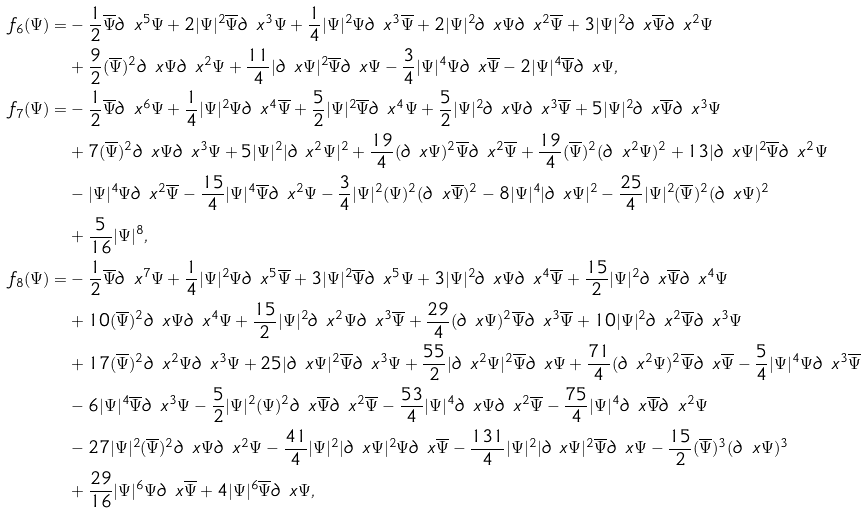<formula> <loc_0><loc_0><loc_500><loc_500>f _ { 6 } ( \Psi ) = & - \frac { 1 } { 2 } \overline { \Psi } \partial _ { \ } x ^ { 5 } \Psi + 2 | \Psi | ^ { 2 } \overline { \Psi } \partial _ { \ } x ^ { 3 } \Psi + \frac { 1 } { 4 } | \Psi | ^ { 2 } \Psi \partial _ { \ } x ^ { 3 } \overline { \Psi } + 2 | \Psi | ^ { 2 } \partial _ { \ } x \Psi \partial _ { \ } x ^ { 2 } \overline { \Psi } + 3 | \Psi | ^ { 2 } \partial _ { \ } x \overline { \Psi } \partial _ { \ } x ^ { 2 } \Psi \\ & + \frac { 9 } { 2 } ( \overline { \Psi } ) ^ { 2 } \partial _ { \ } x \Psi \partial _ { \ } x ^ { 2 } \Psi + \frac { 1 1 } { 4 } | \partial _ { \ } x \Psi | ^ { 2 } \overline { \Psi } \partial _ { \ } x \Psi - \frac { 3 } { 4 } | \Psi | ^ { 4 } \Psi \partial _ { \ } x \overline { \Psi } - 2 | \Psi | ^ { 4 } \overline { \Psi } \partial _ { \ } x \Psi , \\ f _ { 7 } ( \Psi ) = & - \frac { 1 } { 2 } \overline { \Psi } \partial _ { \ } x ^ { 6 } \Psi + \frac { 1 } { 4 } | \Psi | ^ { 2 } \Psi \partial _ { \ } x ^ { 4 } \overline { \Psi } + \frac { 5 } { 2 } | \Psi | ^ { 2 } \overline { \Psi } \partial _ { \ } x ^ { 4 } \Psi + \frac { 5 } { 2 } | \Psi | ^ { 2 } \partial _ { \ } x \Psi \partial _ { \ } x ^ { 3 } \overline { \Psi } + 5 | \Psi | ^ { 2 } \partial _ { \ } x \overline { \Psi } \partial _ { \ } x ^ { 3 } \Psi \\ & + 7 ( \overline { \Psi } ) ^ { 2 } \partial _ { \ } x \Psi \partial _ { \ } x ^ { 3 } \Psi + 5 | \Psi | ^ { 2 } | \partial _ { \ } x ^ { 2 } \Psi | ^ { 2 } + \frac { 1 9 } { 4 } ( \partial _ { \ } x \Psi ) ^ { 2 } \overline { \Psi } \partial _ { \ } x ^ { 2 } \overline { \Psi } + \frac { 1 9 } { 4 } ( \overline { \Psi } ) ^ { 2 } ( \partial _ { \ } x ^ { 2 } \Psi ) ^ { 2 } + 1 3 | \partial _ { \ } x \Psi | ^ { 2 } \overline { \Psi } \partial _ { \ } x ^ { 2 } \Psi \\ & - | \Psi | ^ { 4 } \Psi \partial _ { \ } x ^ { 2 } \overline { \Psi } - \frac { 1 5 } { 4 } | \Psi | ^ { 4 } \overline { \Psi } \partial _ { \ } x ^ { 2 } \Psi - \frac { 3 } { 4 } | \Psi | ^ { 2 } ( \Psi ) ^ { 2 } ( \partial _ { \ } x \overline { \Psi } ) ^ { 2 } - 8 | \Psi | ^ { 4 } | \partial _ { \ } x \Psi | ^ { 2 } - \frac { 2 5 } { 4 } | \Psi | ^ { 2 } ( \overline { \Psi } ) ^ { 2 } ( \partial _ { \ } x \Psi ) ^ { 2 } \\ & + \frac { 5 } { 1 6 } | \Psi | ^ { 8 } , \\ f _ { 8 } ( \Psi ) = & - \frac { 1 } { 2 } \overline { \Psi } \partial _ { \ } x ^ { 7 } \Psi + \frac { 1 } { 4 } | \Psi | ^ { 2 } \Psi \partial _ { \ } x ^ { 5 } \overline { \Psi } + 3 | \Psi | ^ { 2 } \overline { \Psi } \partial _ { \ } x ^ { 5 } \Psi + 3 | \Psi | ^ { 2 } \partial _ { \ } x \Psi \partial _ { \ } x ^ { 4 } \overline { \Psi } + \frac { 1 5 } { 2 } | \Psi | ^ { 2 } \partial _ { \ } x \overline { \Psi } \partial _ { \ } x ^ { 4 } \Psi \\ & + 1 0 ( \overline { \Psi } ) ^ { 2 } \partial _ { \ } x \Psi \partial _ { \ } x ^ { 4 } \Psi + \frac { 1 5 } { 2 } | \Psi | ^ { 2 } \partial _ { \ } x ^ { 2 } \Psi \partial _ { \ } x ^ { 3 } \overline { \Psi } + \frac { 2 9 } { 4 } ( \partial _ { \ } x \Psi ) ^ { 2 } \overline { \Psi } \partial _ { \ } x ^ { 3 } \overline { \Psi } + 1 0 | \Psi | ^ { 2 } \partial _ { \ } x ^ { 2 } \overline { \Psi } \partial _ { \ } x ^ { 3 } \Psi \\ & + 1 7 ( \overline { \Psi } ) ^ { 2 } \partial _ { \ } x ^ { 2 } \Psi \partial _ { \ } x ^ { 3 } \Psi + 2 5 | \partial _ { \ } x \Psi | ^ { 2 } \overline { \Psi } \partial _ { \ } x ^ { 3 } \Psi + \frac { 5 5 } { 2 } | \partial _ { \ } x ^ { 2 } \Psi | ^ { 2 } \overline { \Psi } \partial _ { \ } x \Psi + \frac { 7 1 } { 4 } ( \partial _ { \ } x ^ { 2 } \Psi ) ^ { 2 } \overline { \Psi } \partial _ { \ } x \overline { \Psi } - \frac { 5 } { 4 } | \Psi | ^ { 4 } \Psi \partial _ { \ } x ^ { 3 } \overline { \Psi } \\ & - 6 | \Psi | ^ { 4 } \overline { \Psi } \partial _ { \ } x ^ { 3 } \Psi - \frac { 5 } { 2 } | \Psi | ^ { 2 } ( \Psi ) ^ { 2 } \partial _ { \ } x \overline { \Psi } \partial _ { \ } x ^ { 2 } \overline { \Psi } - \frac { 5 3 } { 4 } | \Psi | ^ { 4 } \partial _ { \ } x \Psi \partial _ { \ } x ^ { 2 } \overline { \Psi } - \frac { 7 5 } { 4 } | \Psi | ^ { 4 } \partial _ { \ } x \overline { \Psi } \partial _ { \ } x ^ { 2 } \Psi \\ & - 2 7 | \Psi | ^ { 2 } ( \overline { \Psi } ) ^ { 2 } \partial _ { \ } x \Psi \partial _ { \ } x ^ { 2 } \Psi - \frac { 4 1 } { 4 } | \Psi | ^ { 2 } | \partial _ { \ } x \Psi | ^ { 2 } \Psi \partial _ { \ } x \overline { \Psi } - \frac { 1 3 1 } { 4 } | \Psi | ^ { 2 } | \partial _ { \ } x \Psi | ^ { 2 } \overline { \Psi } \partial _ { \ } x \Psi - \frac { 1 5 } { 2 } ( \overline { \Psi } ) ^ { 3 } ( \partial _ { \ } x \Psi ) ^ { 3 } \\ & + \frac { 2 9 } { 1 6 } | \Psi | ^ { 6 } \Psi \partial _ { \ } x \overline { \Psi } + 4 | \Psi | ^ { 6 } \overline { \Psi } \partial _ { \ } x \Psi ,</formula> 